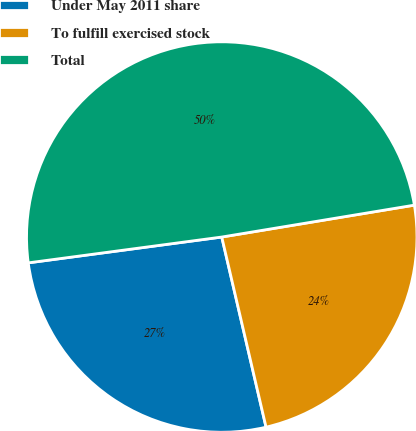Convert chart. <chart><loc_0><loc_0><loc_500><loc_500><pie_chart><fcel>Under May 2011 share<fcel>To fulfill exercised stock<fcel>Total<nl><fcel>26.53%<fcel>23.97%<fcel>49.5%<nl></chart> 